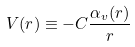<formula> <loc_0><loc_0><loc_500><loc_500>V ( r ) \equiv - C \frac { \alpha _ { v } ( r ) } { r }</formula> 